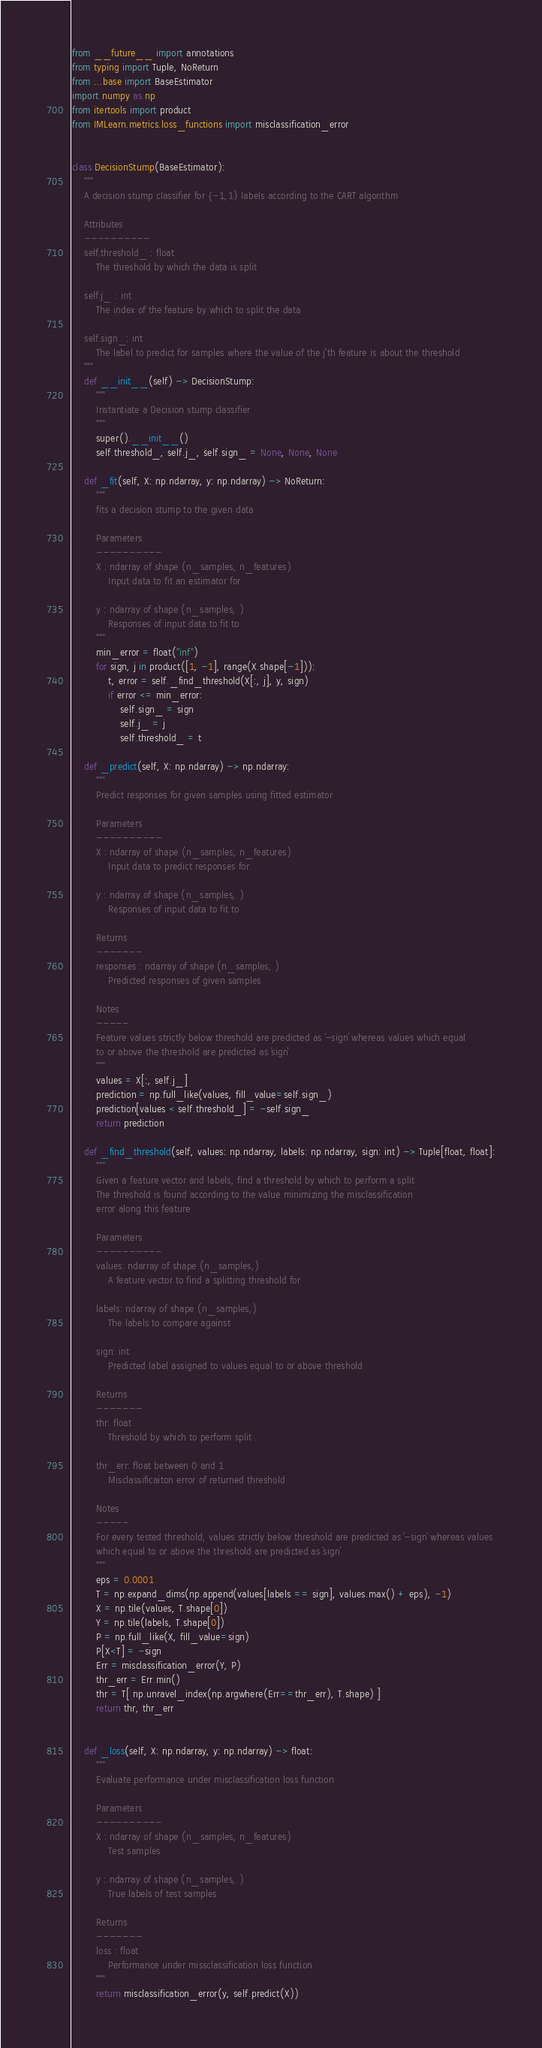Convert code to text. <code><loc_0><loc_0><loc_500><loc_500><_Python_>from __future__ import annotations
from typing import Tuple, NoReturn
from ...base import BaseEstimator
import numpy as np
from itertools import product
from IMLearn.metrics.loss_functions import misclassification_error


class DecisionStump(BaseEstimator):
    """
    A decision stump classifier for {-1,1} labels according to the CART algorithm

    Attributes
    ----------
    self.threshold_ : float
        The threshold by which the data is split

    self.j_ : int
        The index of the feature by which to split the data

    self.sign_: int
        The label to predict for samples where the value of the j'th feature is about the threshold
    """
    def __init__(self) -> DecisionStump:
        """
        Instantiate a Decision stump classifier
        """
        super().__init__()
        self.threshold_, self.j_, self.sign_ = None, None, None

    def _fit(self, X: np.ndarray, y: np.ndarray) -> NoReturn:
        """
        fits a decision stump to the given data

        Parameters
        ----------
        X : ndarray of shape (n_samples, n_features)
            Input data to fit an estimator for

        y : ndarray of shape (n_samples, )
            Responses of input data to fit to
        """
        min_error = float("inf")
        for sign, j in product([1, -1], range(X.shape[-1])):
            t, error = self._find_threshold(X[:, j], y, sign)
            if error <= min_error:
                self.sign_ = sign
                self.j_ = j
                self.threshold_ = t

    def _predict(self, X: np.ndarray) -> np.ndarray:
        """
        Predict responses for given samples using fitted estimator

        Parameters
        ----------
        X : ndarray of shape (n_samples, n_features)
            Input data to predict responses for

        y : ndarray of shape (n_samples, )
            Responses of input data to fit to

        Returns
        -------
        responses : ndarray of shape (n_samples, )
            Predicted responses of given samples

        Notes
        -----
        Feature values strictly below threshold are predicted as `-sign` whereas values which equal
        to or above the threshold are predicted as `sign`
        """
        values = X[:, self.j_]
        prediction = np.full_like(values, fill_value=self.sign_)
        prediction[values < self.threshold_] = -self.sign_
        return prediction

    def _find_threshold(self, values: np.ndarray, labels: np.ndarray, sign: int) -> Tuple[float, float]:
        """
        Given a feature vector and labels, find a threshold by which to perform a split
        The threshold is found according to the value minimizing the misclassification
        error along this feature

        Parameters
        ----------
        values: ndarray of shape (n_samples,)
            A feature vector to find a splitting threshold for

        labels: ndarray of shape (n_samples,)
            The labels to compare against

        sign: int
            Predicted label assigned to values equal to or above threshold

        Returns
        -------
        thr: float
            Threshold by which to perform split

        thr_err: float between 0 and 1
            Misclassificaiton error of returned threshold

        Notes
        -----
        For every tested threshold, values strictly below threshold are predicted as `-sign` whereas values
        which equal to or above the threshold are predicted as `sign`
        """
        eps = 0.0001
        T = np.expand_dims(np.append(values[labels == sign], values.max() + eps), -1)
        X = np.tile(values, T.shape[0])
        Y = np.tile(labels, T.shape[0])
        P = np.full_like(X, fill_value=sign)
        P[X<T] = -sign
        Err = misclassification_error(Y, P)
        thr_err = Err.min()
        thr = T[ np.unravel_index(np.argwhere(Err==thr_err), T.shape) ]
        return thr, thr_err


    def _loss(self, X: np.ndarray, y: np.ndarray) -> float:
        """
        Evaluate performance under misclassification loss function

        Parameters
        ----------
        X : ndarray of shape (n_samples, n_features)
            Test samples

        y : ndarray of shape (n_samples, )
            True labels of test samples

        Returns
        -------
        loss : float
            Performance under missclassification loss function
        """
        return misclassification_error(y, self.predict(X))
</code> 